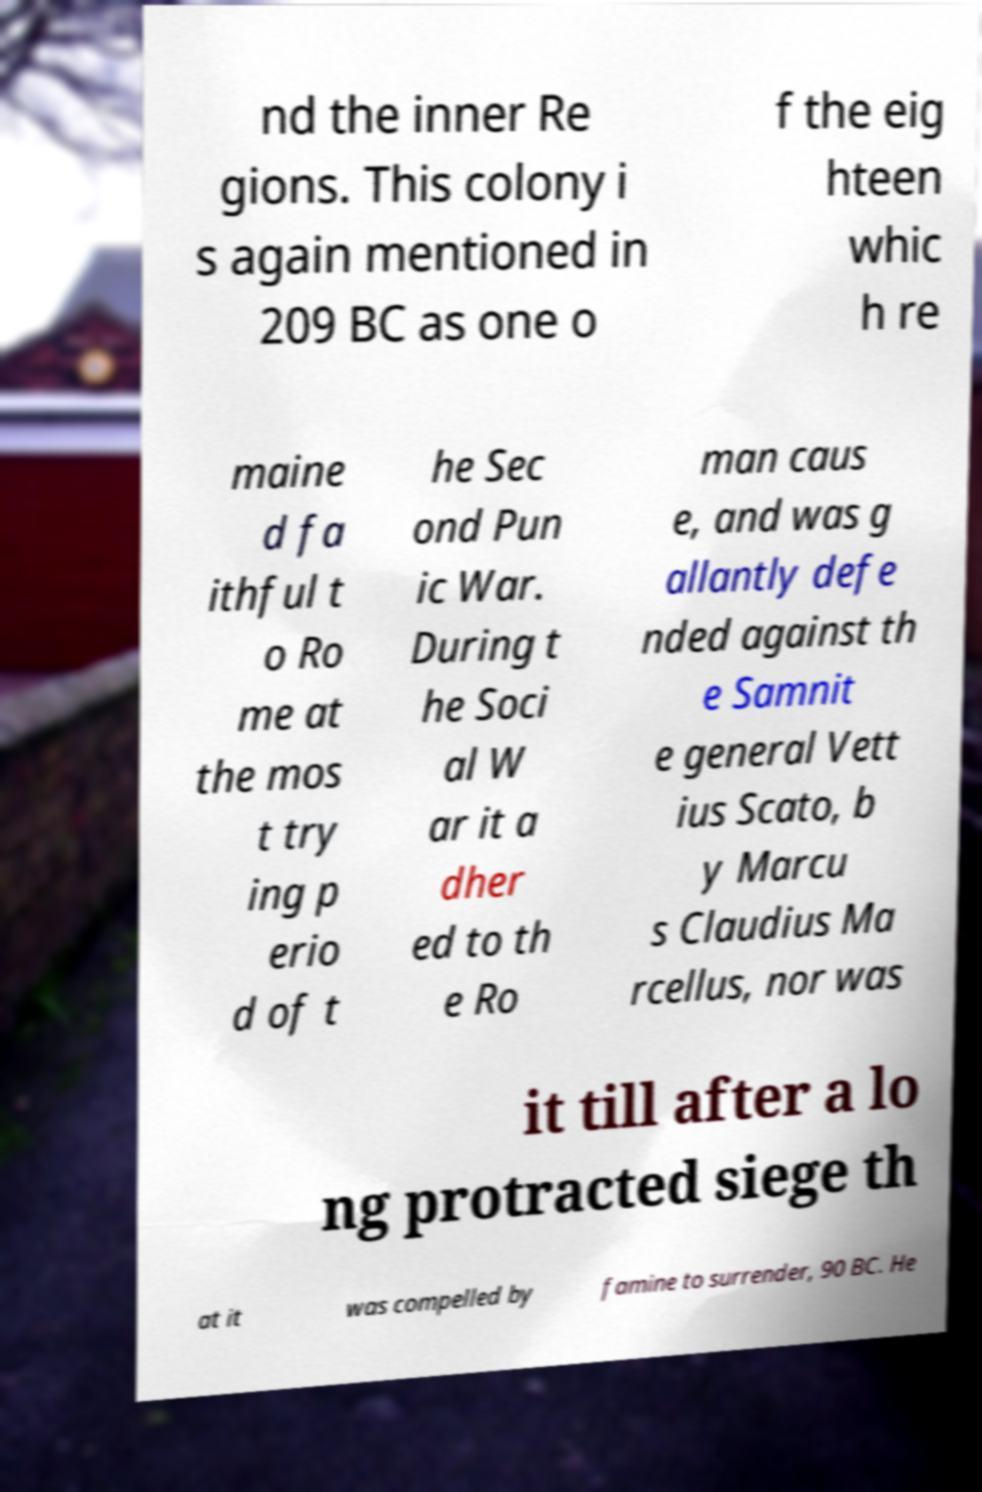Can you accurately transcribe the text from the provided image for me? nd the inner Re gions. This colony i s again mentioned in 209 BC as one o f the eig hteen whic h re maine d fa ithful t o Ro me at the mos t try ing p erio d of t he Sec ond Pun ic War. During t he Soci al W ar it a dher ed to th e Ro man caus e, and was g allantly defe nded against th e Samnit e general Vett ius Scato, b y Marcu s Claudius Ma rcellus, nor was it till after a lo ng protracted siege th at it was compelled by famine to surrender, 90 BC. He 